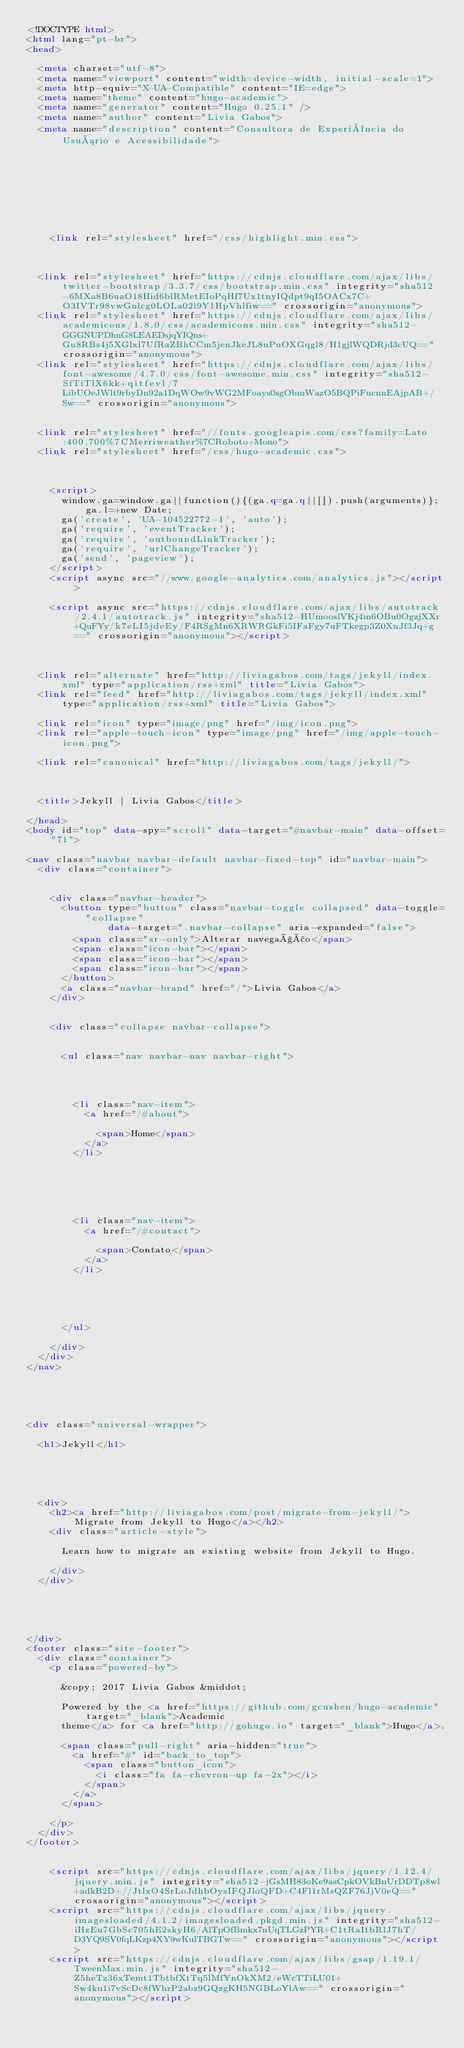<code> <loc_0><loc_0><loc_500><loc_500><_HTML_><!DOCTYPE html>
<html lang="pt-br">
<head>

  <meta charset="utf-8">
  <meta name="viewport" content="width=device-width, initial-scale=1">
  <meta http-equiv="X-UA-Compatible" content="IE=edge">
  <meta name="theme" content="hugo-academic">
  <meta name="generator" content="Hugo 0.25.1" />
  <meta name="author" content="Livia Gabos">
  <meta name="description" content="Consultora de Experiência do Usuário e Acessibilidade">

  
  
  
    
  
  
    
    
    <link rel="stylesheet" href="/css/highlight.min.css">
    
  
  
  <link rel="stylesheet" href="https://cdnjs.cloudflare.com/ajax/libs/twitter-bootstrap/3.3.7/css/bootstrap.min.css" integrity="sha512-6MXa8B6uaO18Hid6blRMetEIoPqHf7Ux1tnyIQdpt9qI5OACx7C+O3IVTr98vwGnlcg0LOLa02i9Y1HpVhlfiw==" crossorigin="anonymous">
  <link rel="stylesheet" href="https://cdnjs.cloudflare.com/ajax/libs/academicons/1.8.0/css/academicons.min.css" integrity="sha512-GGGNUPDhnG8LEAEDsjqYIQns+Gu8RBs4j5XGlxl7UfRaZBhCCm5jenJkeJL8uPuOXGqgl8/H1gjlWQDRjd3cUQ==" crossorigin="anonymous">
  <link rel="stylesheet" href="https://cdnjs.cloudflare.com/ajax/libs/font-awesome/4.7.0/css/font-awesome.min.css" integrity="sha512-SfTiTlX6kk+qitfevl/7LibUOeJWlt9rbyDn92a1DqWOw9vWG2MFoays0sgObmWazO5BQPiFucnnEAjpAB+/Sw==" crossorigin="anonymous">
  
  
  <link rel="stylesheet" href="//fonts.googleapis.com/css?family=Lato:400,700%7CMerriweather%7CRoboto+Mono">
  <link rel="stylesheet" href="/css/hugo-academic.css">
  

  
    <script>
      window.ga=window.ga||function(){(ga.q=ga.q||[]).push(arguments)};ga.l=+new Date;
      ga('create', 'UA-104522772-1', 'auto');
      ga('require', 'eventTracker');
      ga('require', 'outboundLinkTracker');
      ga('require', 'urlChangeTracker');
      ga('send', 'pageview');
    </script>
    <script async src="//www.google-analytics.com/analytics.js"></script>
    
    <script async src="https://cdnjs.cloudflare.com/ajax/libs/autotrack/2.4.1/autotrack.js" integrity="sha512-HUmooslVKj4m6OBu0OgzjXXr+QuFYy/k7eLI5jdeEy/F4RSgMn6XRWRGkFi5IFaFgy7uFTkegp3Z0XnJf3Jq+g==" crossorigin="anonymous"></script>
    
  

  <link rel="alternate" href="http://liviagabos.com/tags/jekyll/index.xml" type="application/rss+xml" title="Livia Gabos">
  <link rel="feed" href="http://liviagabos.com/tags/jekyll/index.xml" type="application/rss+xml" title="Livia Gabos">

  <link rel="icon" type="image/png" href="/img/icon.png">
  <link rel="apple-touch-icon" type="image/png" href="/img/apple-touch-icon.png">

  <link rel="canonical" href="http://liviagabos.com/tags/jekyll/">

  

  <title>Jekyll | Livia Gabos</title>

</head>
<body id="top" data-spy="scroll" data-target="#navbar-main" data-offset="71">

<nav class="navbar navbar-default navbar-fixed-top" id="navbar-main">
  <div class="container">

    
    <div class="navbar-header">
      <button type="button" class="navbar-toggle collapsed" data-toggle="collapse"
              data-target=".navbar-collapse" aria-expanded="false">
        <span class="sr-only">Alterar navegação</span>
        <span class="icon-bar"></span>
        <span class="icon-bar"></span>
        <span class="icon-bar"></span>
      </button>
      <a class="navbar-brand" href="/">Livia Gabos</a>
    </div>

    
    <div class="collapse navbar-collapse">

      
      <ul class="nav navbar-nav navbar-right">
        

        

        <li class="nav-item">
          <a href="/#about">
            
            <span>Home</span>
          </a>
        </li>

        
        

        

        <li class="nav-item">
          <a href="/#contact">
            
            <span>Contato</span>
          </a>
        </li>

        
        

        
      </ul>

    </div>
  </div>
</nav>





<div class="universal-wrapper">

  <h1>Jekyll</h1>

  

  
  
  <div>
    <h2><a href="http://liviagabos.com/post/migrate-from-jekyll/">Migrate from Jekyll to Hugo</a></h2>
    <div class="article-style">
      
      Learn how to migrate an existing website from Jekyll to Hugo.
      
    </div>
  </div>
  

  


</div>
<footer class="site-footer">
  <div class="container">
    <p class="powered-by">

      &copy; 2017 Livia Gabos &middot; 

      Powered by the <a href="https://github.com/gcushen/hugo-academic" target="_blank">Academic
      theme</a> for <a href="http://gohugo.io" target="_blank">Hugo</a>.

      <span class="pull-right" aria-hidden="true">
        <a href="#" id="back_to_top">
          <span class="button_icon">
            <i class="fa fa-chevron-up fa-2x"></i>
          </span>
        </a>
      </span>

    </p>
  </div>
</footer>

    
    <script src="https://cdnjs.cloudflare.com/ajax/libs/jquery/1.12.4/jquery.min.js" integrity="sha512-jGsMH83oKe9asCpkOVkBnUrDDTp8wl+adkB2D+//JtlxO4SrLoJdhbOysIFQJloQFD+C4Fl1rMsQZF76JjV0eQ==" crossorigin="anonymous"></script>
    <script src="https://cdnjs.cloudflare.com/ajax/libs/jquery.imagesloaded/4.1.2/imagesloaded.pkgd.min.js" integrity="sha512-iHzEu7GbSc705hE2skyH6/AlTpOfBmkx7nUqTLGzPYR+C1tRaItbRlJ7hT/D3YQ9SV0fqLKzp4XY9wKulTBGTw==" crossorigin="anonymous"></script>
    <script src="https://cdnjs.cloudflare.com/ajax/libs/gsap/1.19.1/TweenMax.min.js" integrity="sha512-Z5heTz36xTemt1TbtbfXtTq5lMfYnOkXM2/eWcTTiLU01+Sw4ku1i7vScDc8fWhrP2abz9GQzgKH5NGBLoYlAw==" crossorigin="anonymous"></script></code> 